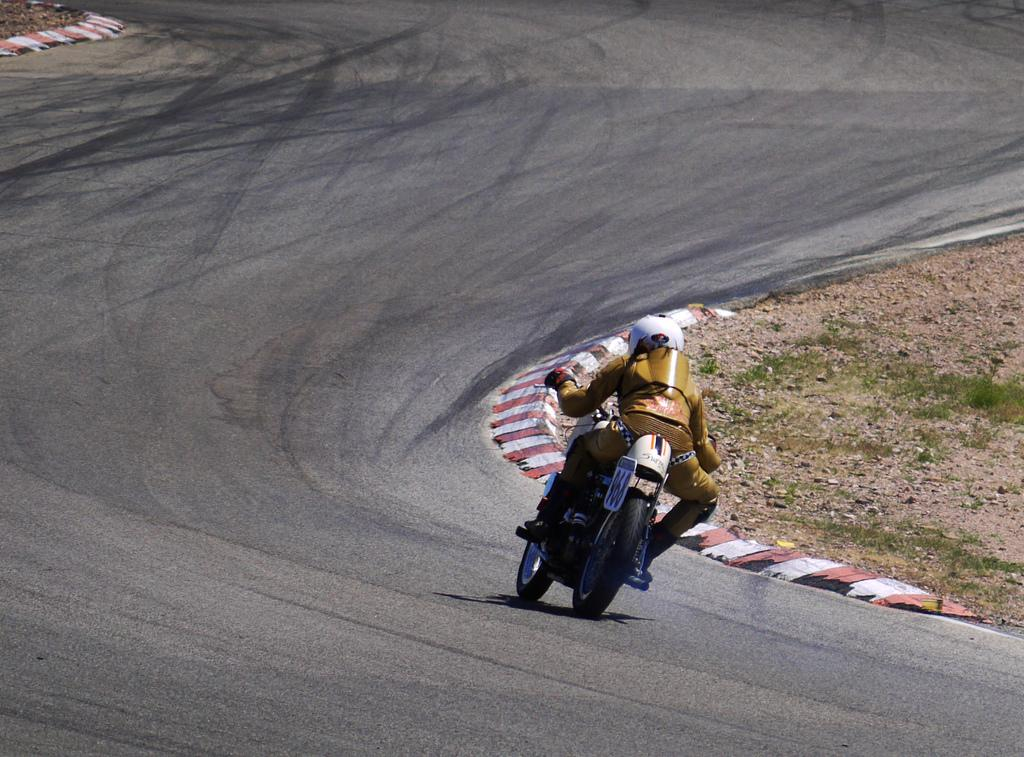What is happening in the image? There is a person in the image, and they are riding a motor vehicle. Where is the motor vehicle located? The motor vehicle is on the road. What answer does the person's mouth give in the image? There is no indication in the image that the person is giving an answer or that their mouth is visible. 